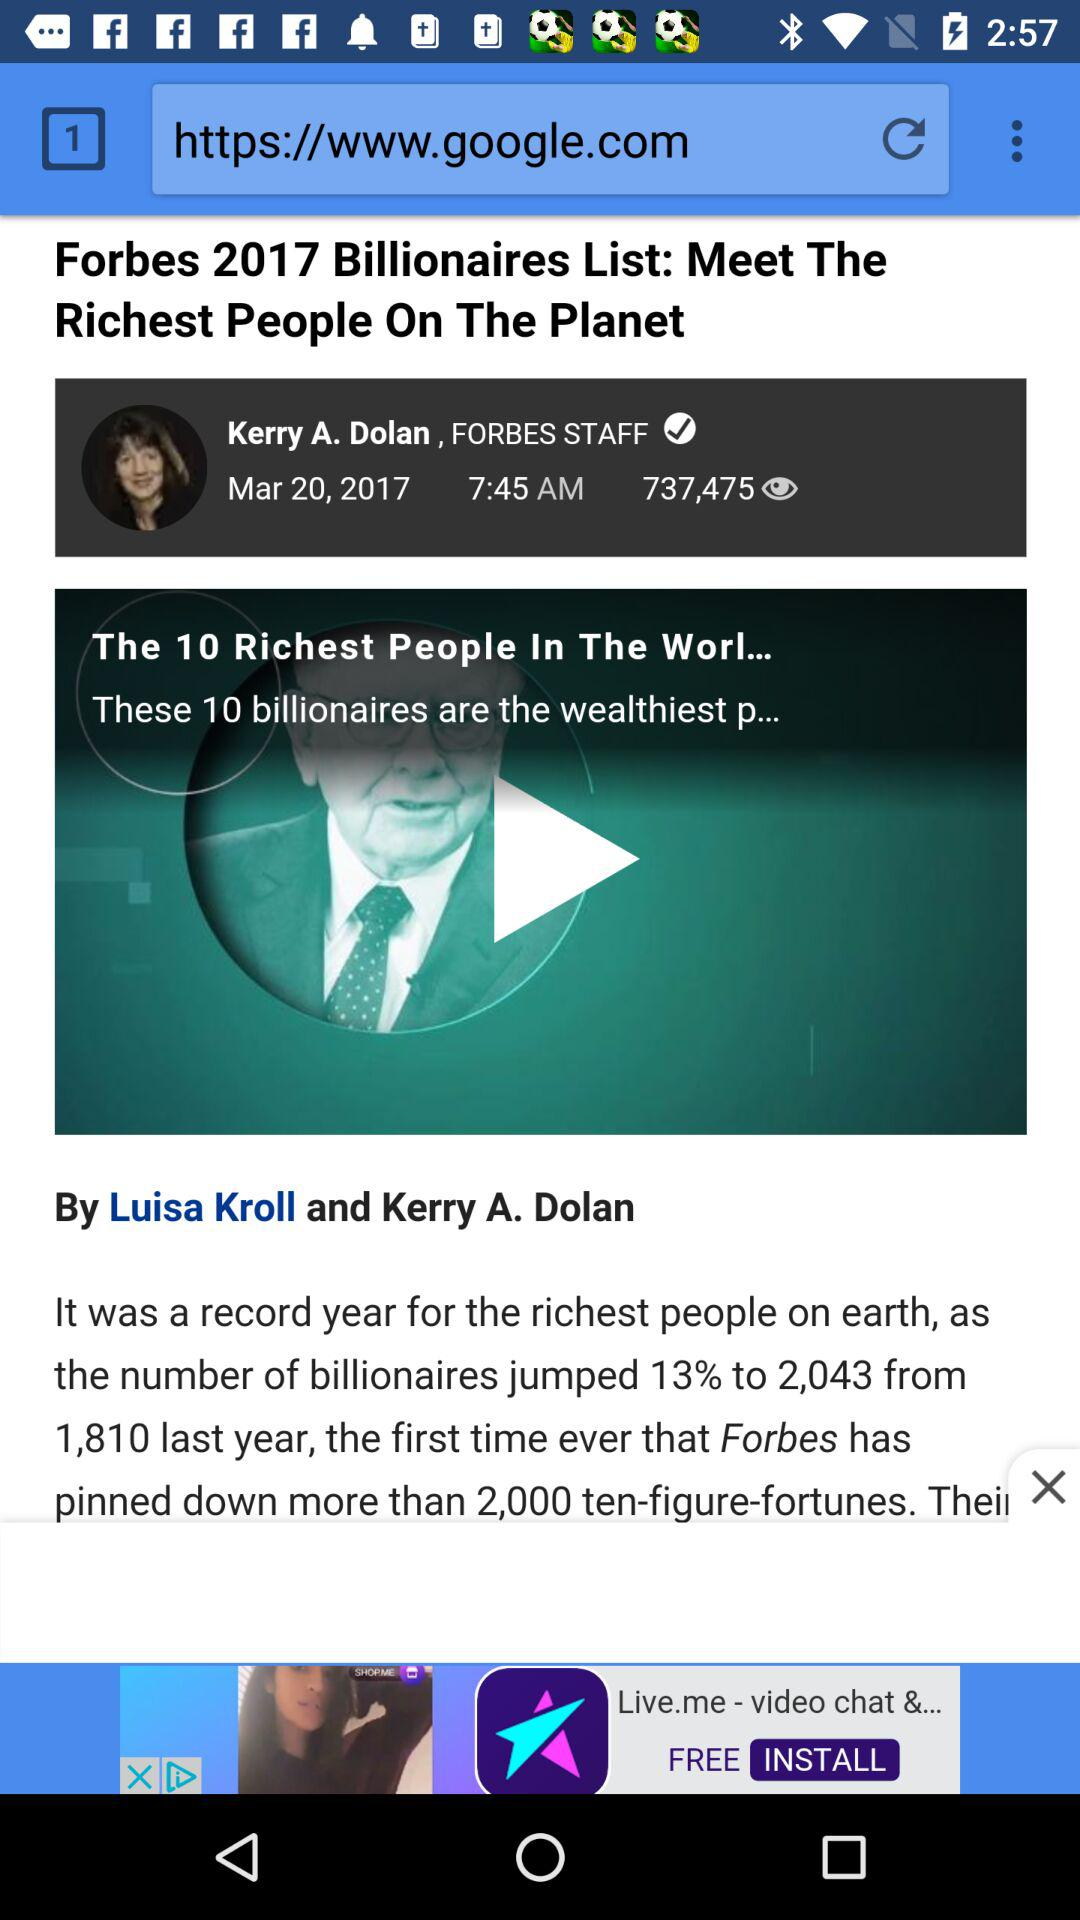When and at what time was the news about "Forbes 2017 Billionaires List: Meet The Richest People On The Planet" published? The news about "Forbes 2017 Billionaires List: Meet The Richest People On The Planet" was published on Mar 20, 2017 at 7:45 AM. 